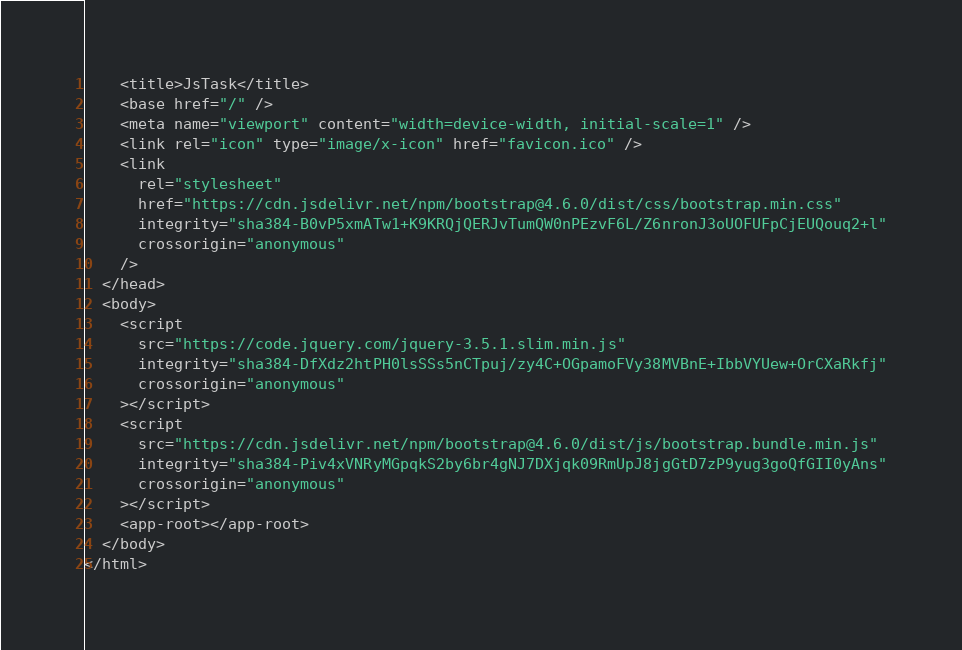Convert code to text. <code><loc_0><loc_0><loc_500><loc_500><_HTML_>    <title>JsTask</title>
    <base href="/" />
    <meta name="viewport" content="width=device-width, initial-scale=1" />
    <link rel="icon" type="image/x-icon" href="favicon.ico" />
    <link
      rel="stylesheet"
      href="https://cdn.jsdelivr.net/npm/bootstrap@4.6.0/dist/css/bootstrap.min.css"
      integrity="sha384-B0vP5xmATw1+K9KRQjQERJvTumQW0nPEzvF6L/Z6nronJ3oUOFUFpCjEUQouq2+l"
      crossorigin="anonymous"
    />
  </head>
  <body>
    <script
      src="https://code.jquery.com/jquery-3.5.1.slim.min.js"
      integrity="sha384-DfXdz2htPH0lsSSs5nCTpuj/zy4C+OGpamoFVy38MVBnE+IbbVYUew+OrCXaRkfj"
      crossorigin="anonymous"
    ></script>
    <script
      src="https://cdn.jsdelivr.net/npm/bootstrap@4.6.0/dist/js/bootstrap.bundle.min.js"
      integrity="sha384-Piv4xVNRyMGpqkS2by6br4gNJ7DXjqk09RmUpJ8jgGtD7zP9yug3goQfGII0yAns"
      crossorigin="anonymous"
    ></script>
    <app-root></app-root>
  </body>
</html>
</code> 